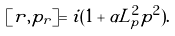<formula> <loc_0><loc_0><loc_500><loc_500>[ r , p _ { r } ] = i ( 1 + \alpha L _ { p } ^ { 2 } p ^ { 2 } ) .</formula> 